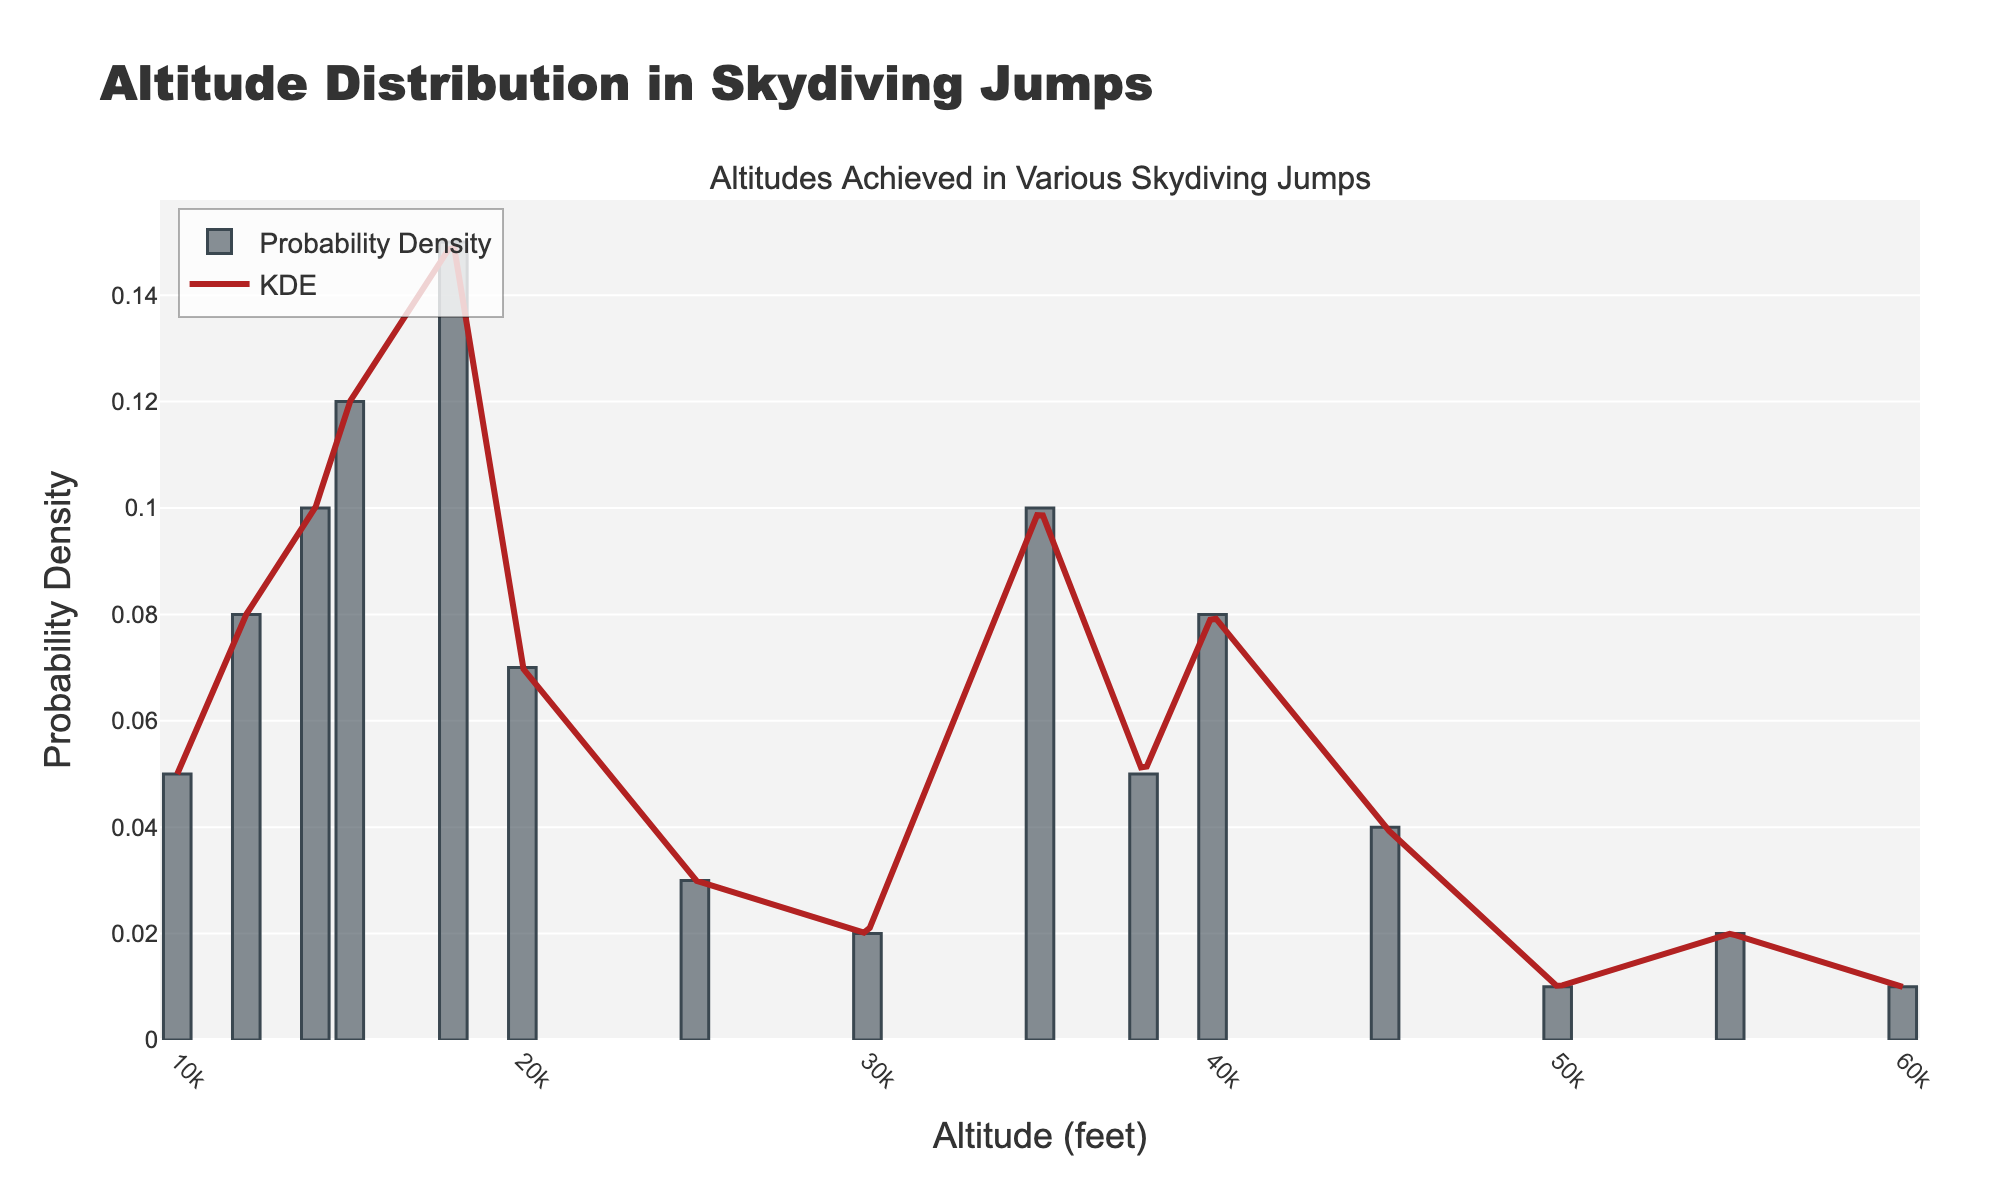How many peaks are visible in the KDE curve? By analyzing the KDE curve, we can count the number of distinct peaks in the curve, representing local maxima in the probability density.
Answer: 3 What is the highest probability density in the dataset, and at what altitude does it occur? The highest probability density can be found by identifying the highest bar in the bar plot and the corresponding altitude on the x-axis.
Answer: 0.15 at 18000 feet What altitudes have a probability density greater than 0.1? By checking the bar heights, we can identify altitudes with a probability density higher than 0.1.
Answer: 14000, 15000, 18000, 35000 feet Which altitude has the lowest probability density value, and what is that value? The lowest probability density value corresponds to the smallest bar in the bar plot, with the respective altitude on the x-axis.
Answer: 60000 feet, 0.01 Compare the probability densities at 25000 feet and 40000 feet. Which is higher, and by how much? To compare, we look at the bar heights for 25000 feet and 40000 feet, subtracting the smaller from the larger to find the difference.
Answer: 40000 feet is higher by 0.05 What's the combined probability density of altitudes below 20000 feet? By summing the probability densities of altitudes below 20000 feet: 0.05 + 0.08 + 0.10 + 0.12 + 0.15 + 0.07.
Answer: 0.57 Is there a noticeable difference in probability density between altitudes of 35000 feet and 38000 feet? Compare the height of the bars at these two altitudes to check for differences.
Answer: No significant difference, both are around 0.10 and 0.05 respectively At which altitude ranges do we observe the greatest variance in probability densities? Look for altitude ranges with significant changes in bar heights, indicative of high variance.
Answer: 15000-20000 feet and 35000-40000 feet How does the probability density at 50000 feet compare to that at 60000 feet? To compare, we observe the bar heights at 50000 and 60000 feet. Both values are the same.
Answer: Equal, both are 0.01 